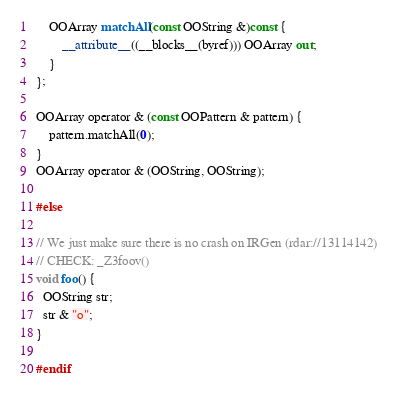<code> <loc_0><loc_0><loc_500><loc_500><_ObjectiveC_>    OOArray matchAll(const OOString &)const {
        __attribute__((__blocks__(byref))) OOArray out;
    }
};

OOArray operator & (const OOPattern & pattern) {
    pattern.matchAll(0);
}
OOArray operator & (OOString, OOString);

#else

// We just make sure there is no crash on IRGen (rdar://13114142)
// CHECK: _Z3foov()
void foo() {
  OOString str;
  str & "o";
}

#endif
</code> 